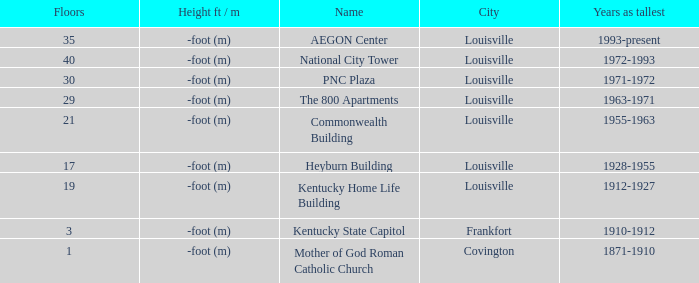In what city does the tallest building have 35 floors? Louisville. 